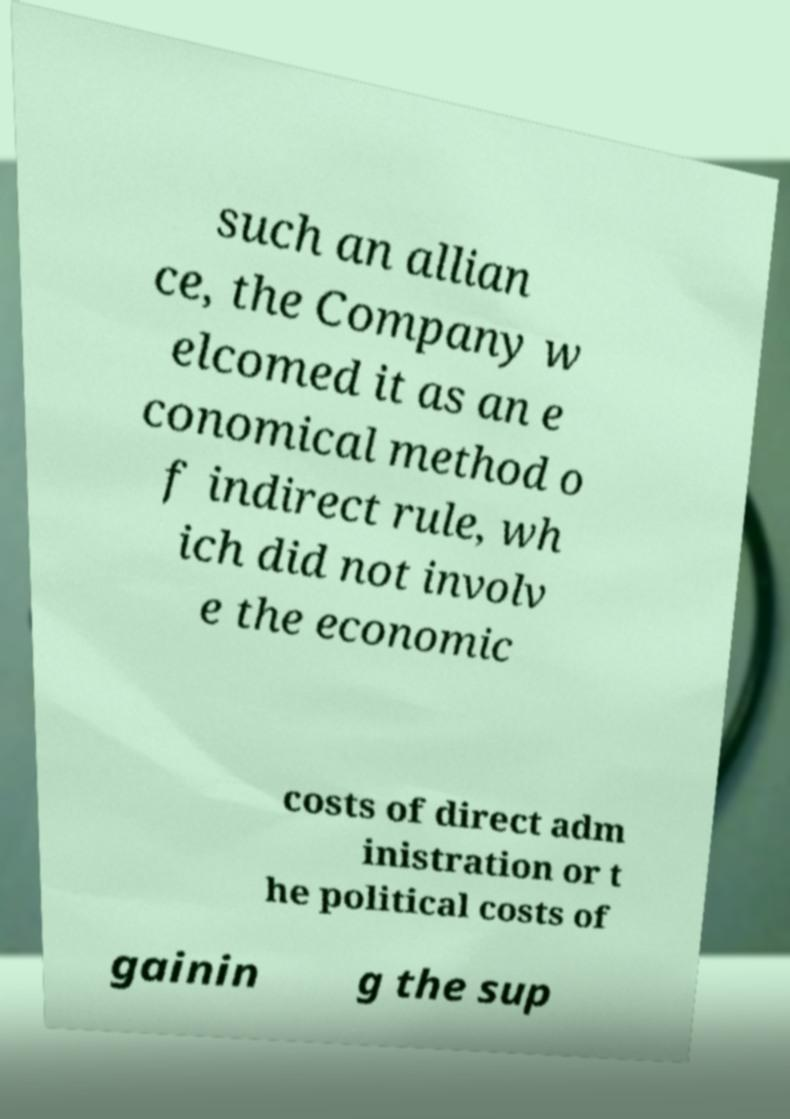I need the written content from this picture converted into text. Can you do that? such an allian ce, the Company w elcomed it as an e conomical method o f indirect rule, wh ich did not involv e the economic costs of direct adm inistration or t he political costs of gainin g the sup 